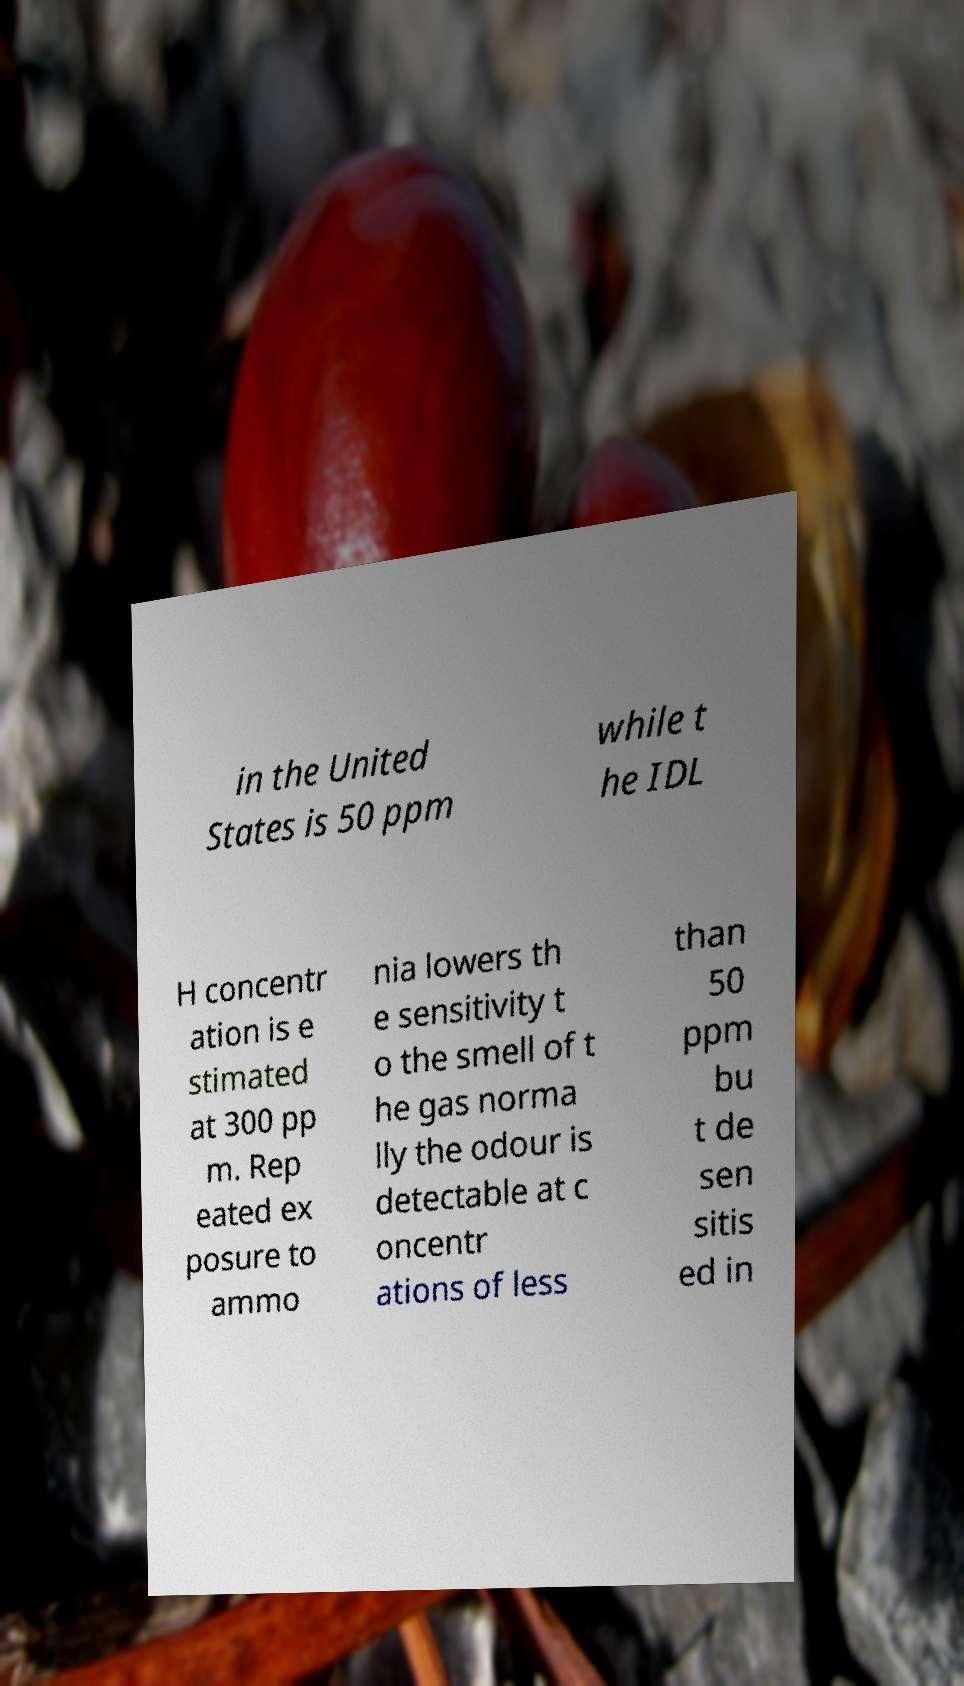Can you read and provide the text displayed in the image?This photo seems to have some interesting text. Can you extract and type it out for me? in the United States is 50 ppm while t he IDL H concentr ation is e stimated at 300 pp m. Rep eated ex posure to ammo nia lowers th e sensitivity t o the smell of t he gas norma lly the odour is detectable at c oncentr ations of less than 50 ppm bu t de sen sitis ed in 